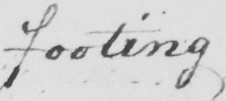What is written in this line of handwriting? footing 